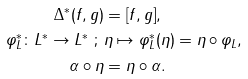<formula> <loc_0><loc_0><loc_500><loc_500>\Delta ^ { * } ( f , g ) & = [ f , g ] , \\ \varphi _ { L } ^ { * } \colon L ^ { * } \rightarrow L ^ { * } \ ; \ & \eta \mapsto \varphi _ { L } ^ { * } ( \eta ) = \eta \circ \varphi _ { L } , \\ \alpha \circ \eta & = \eta \circ \alpha .</formula> 